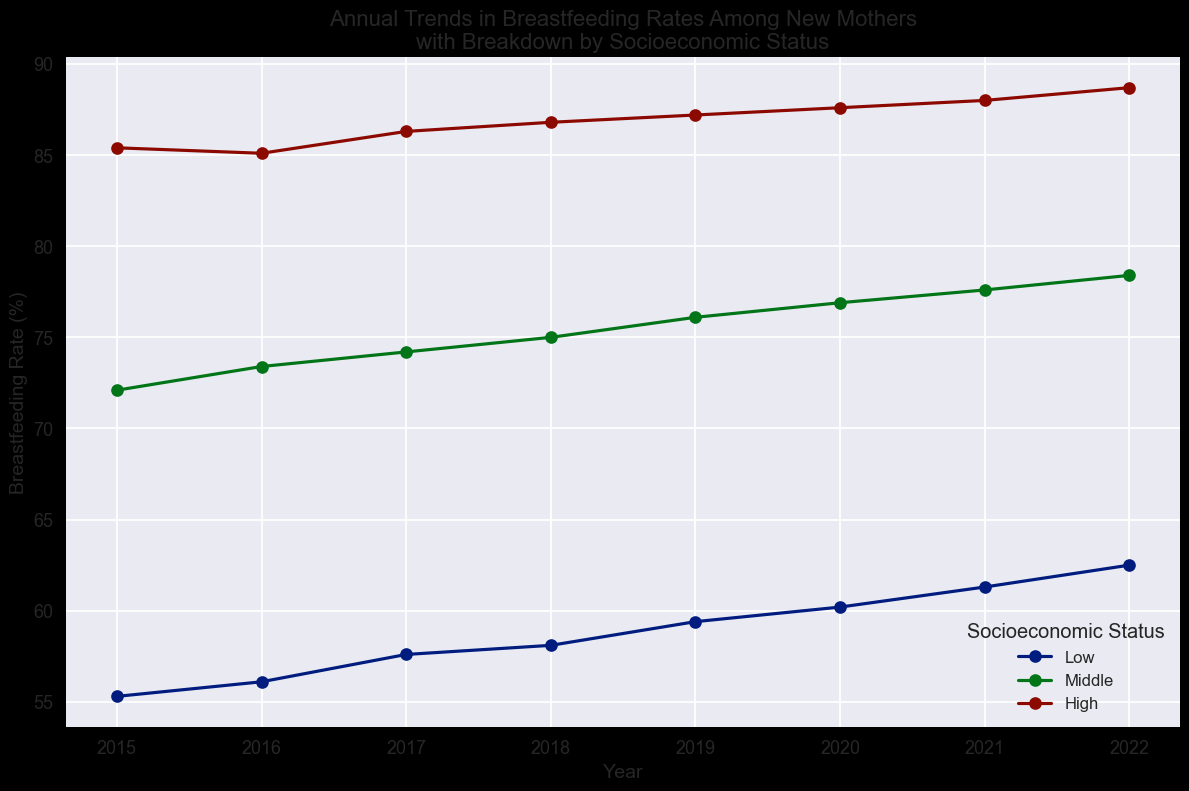Which socioeconomic status group had the highest breastfeeding rate in 2022? To answer this, look at the data points corresponding to the year 2022 for each socioeconomic status. The highest breastfeeding rate for that year is associated with the 'High' socioeconomic status at 88.7%.
Answer: High How did the breastfeeding rate for the 'Low' socioeconomic status group change between 2015 and 2022? Check the breastfeeding rate for the 'Low' socioeconomic status group in 2015, which is 55.3%, and compare it with the rate in 2022, which is 62.5%. The rate increased by 7.2% from 2015 to 2022.
Answer: Increased by 7.2% Between which two consecutive years did the 'Middle' socioeconomic status group see the largest increase in breastfeeding rates? Look at the yearly differences in breastfeeding rates for the 'Middle' socioeconomic status group: 2016 (1.3), 2017 (0.8), 2018 (0.8), 2019 (1.1), 2020 (0.8), 2021 (0.7), and 2022 (0.8). The largest increase occurred between 2015 and 2016, a difference of 1.3%.
Answer: Between 2015 and 2016 Is the trend in breastfeeding rates over the years generally increasing, decreasing, or staying the same for the 'High' socioeconomic status group? Observe the trend line for the 'High' socioeconomic status group from 2015 to 2022. The breastfeeding rates consistently increase each year, from 85.4% in 2015 to 88.7% in 2022, indicating an increasing trend.
Answer: Increasing In which year did the 'Low' socioeconomic status group have the closest breastfeeding rate to 60%? Check the data points for the 'Low' socioeconomic status group across the years. In 2020, the breastfeeding rate was 60.2%, which is closest to 60%.
Answer: 2020 Compare the breastfeeding rates of the 'Middle' and 'High' socioeconomic status groups in 2019. Which is higher and by how much? For 2019, the breastfeeding rate for the 'Middle' socioeconomic group is 76.1%, and for the 'High' group, it is 87.2%. The 'High' group’s rate is higher by 11.1%.
Answer: High by 11.1% What is the average breastfeeding rate for the 'Middle' socioeconomic status group over the given years? To find the average, sum the breastfeeding rates for the 'Middle' socioeconomic status group from 2015 to 2022 (72.1 + 73.4 + 74.2 + 75.0 + 76.1 + 76.9 + 77.6 + 78.4) and divide by the number of years (8). The total is 603.7%, so the average is 603.7 / 8 = 75.5%.
Answer: 75.5% Which year shows the smallest difference in breastfeeding rates between the 'Low' and 'Middle' socioeconomic status groups? Look at the differences between the breastfeeding rates for 'Low' and 'Middle' socioeconomic status groups for each year. The differences are: 2015 (16.8), 2016 (17.3), 2017 (16.6), 2018 (16.9), 2019 (16.7), 2020 (16.7), 2021 (16.3), and 2022 (15.9). The smallest difference is in 2022 with 15.9%.
Answer: 2022 Which socioeconomic status group showed the most consistent year-to-year increase in breastfeeding rates? To find consistency, check the annual rate differences for each group. The 'High' group has the smallest variations: 2016 (-0.3), 2017 (1.2), 2018 (0.5), 2019 (0.4), 2020 (0.4), 2021 (0.4), and 2022 (0.7). The 'High' group consistently increased almost every year and with similar incremental changes.
Answer: High 